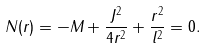Convert formula to latex. <formula><loc_0><loc_0><loc_500><loc_500>N ( r ) = - M + \frac { J ^ { 2 } } { 4 r ^ { 2 } } + \frac { r ^ { 2 } } { l ^ { 2 } } = 0 .</formula> 